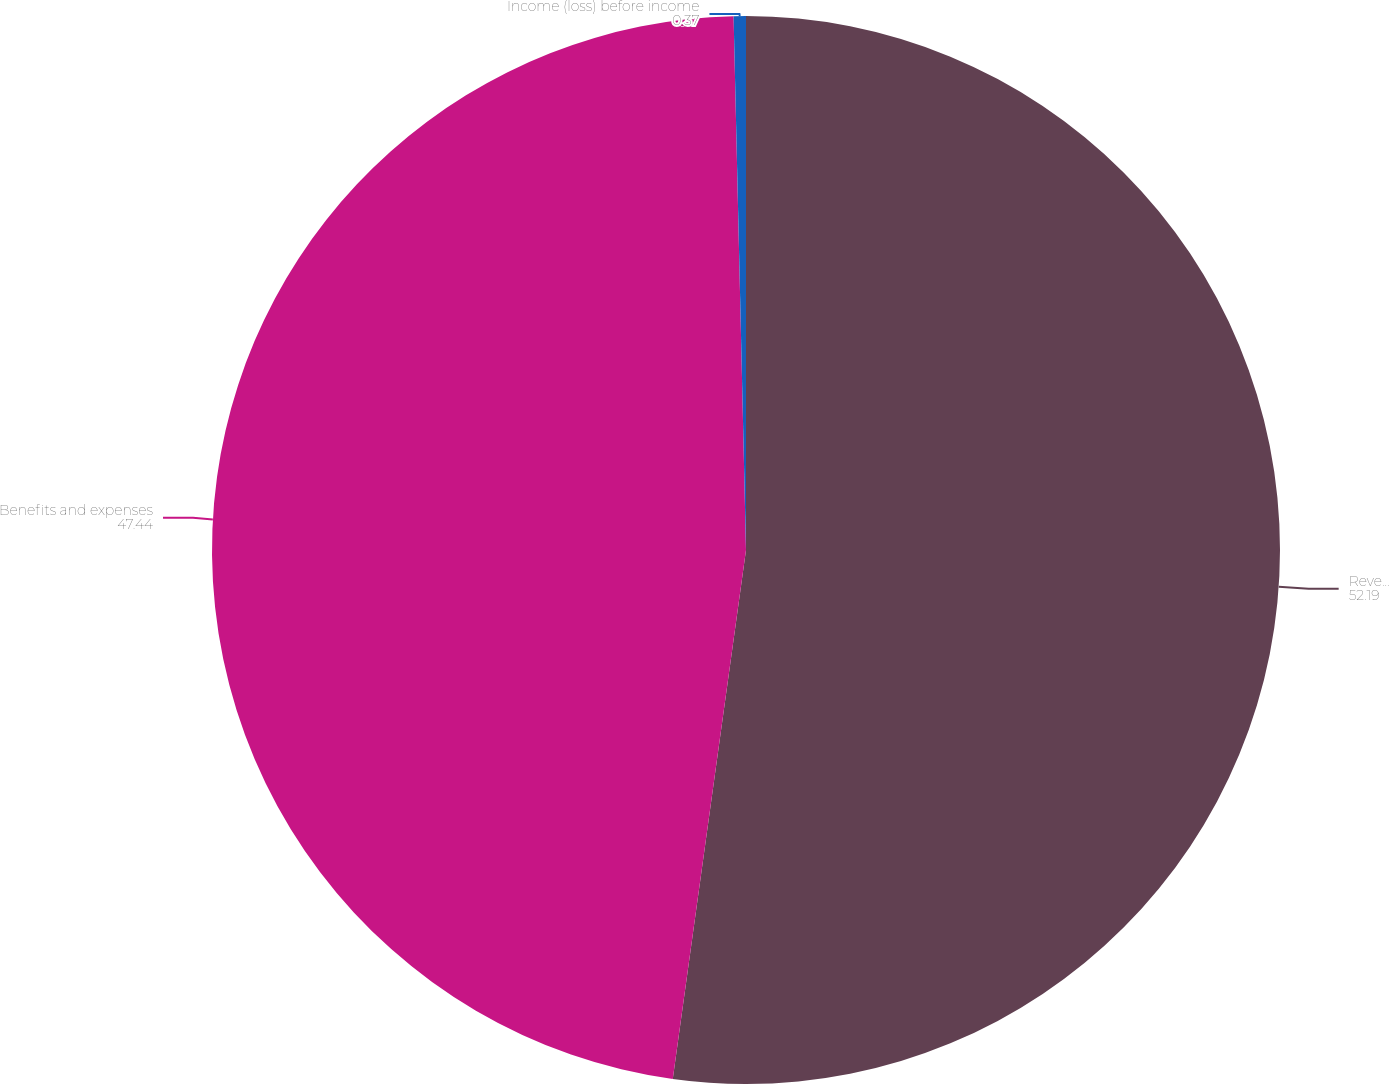<chart> <loc_0><loc_0><loc_500><loc_500><pie_chart><fcel>Revenues<fcel>Benefits and expenses<fcel>Income (loss) before income<nl><fcel>52.19%<fcel>47.44%<fcel>0.37%<nl></chart> 